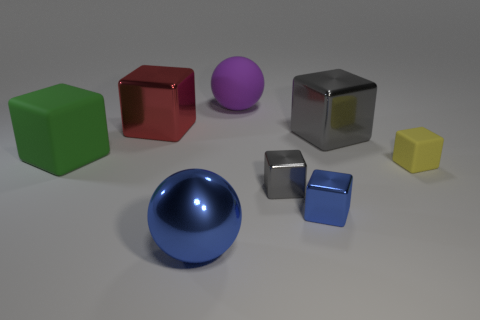Do the gray shiny object behind the yellow cube and the small gray object have the same size?
Your answer should be very brief. No. What is the color of the large thing that is both to the right of the big blue metallic sphere and behind the large gray thing?
Keep it short and to the point. Purple. There is a purple thing that is the same size as the green object; what is its shape?
Offer a terse response. Sphere. Is there a large object that has the same color as the big rubber block?
Ensure brevity in your answer.  No. Is the number of red things in front of the small blue metal block the same as the number of large brown metal cylinders?
Your response must be concise. Yes. Is the color of the big matte block the same as the big matte sphere?
Make the answer very short. No. There is a rubber thing that is both on the left side of the big gray shiny cube and in front of the matte sphere; what is its size?
Provide a short and direct response. Large. The big block that is the same material as the tiny yellow object is what color?
Offer a terse response. Green. How many large purple objects are made of the same material as the yellow block?
Offer a very short reply. 1. Are there the same number of small metal objects that are left of the large gray block and large blue objects that are behind the large blue metal thing?
Provide a short and direct response. No. 